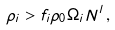<formula> <loc_0><loc_0><loc_500><loc_500>\rho _ { i } > f _ { i } \rho _ { 0 } \Omega _ { i } N ^ { l } \, ,</formula> 